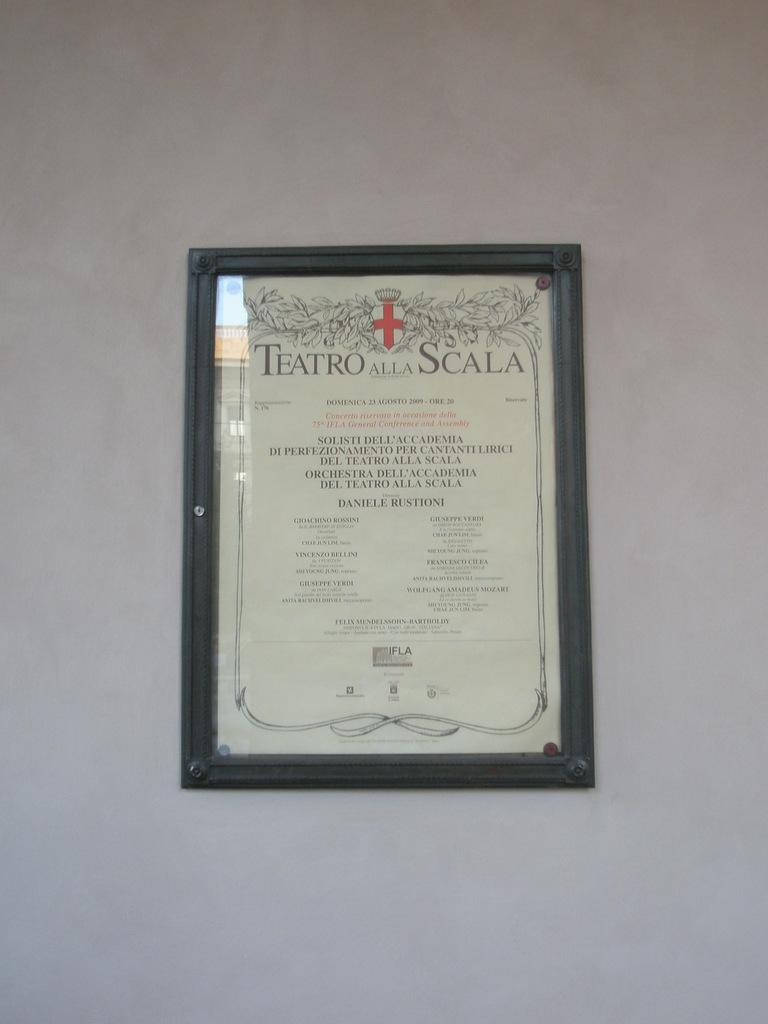<image>
Offer a succinct explanation of the picture presented. A framed certificate with Teatro alla Scala at the top 